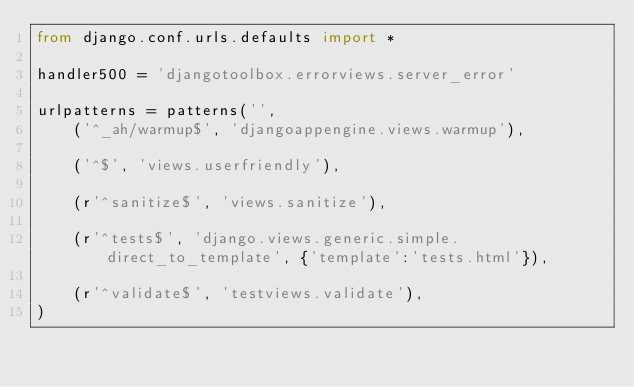<code> <loc_0><loc_0><loc_500><loc_500><_Python_>from django.conf.urls.defaults import *

handler500 = 'djangotoolbox.errorviews.server_error'

urlpatterns = patterns('',
    ('^_ah/warmup$', 'djangoappengine.views.warmup'),
    
    ('^$', 'views.userfriendly'),
    
    (r'^sanitize$', 'views.sanitize'),
    
    (r'^tests$', 'django.views.generic.simple.direct_to_template', {'template':'tests.html'}),
    
    (r'^validate$', 'testviews.validate'),
)
</code> 